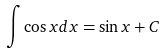<formula> <loc_0><loc_0><loc_500><loc_500>\int \cos x d x = \sin x + C</formula> 